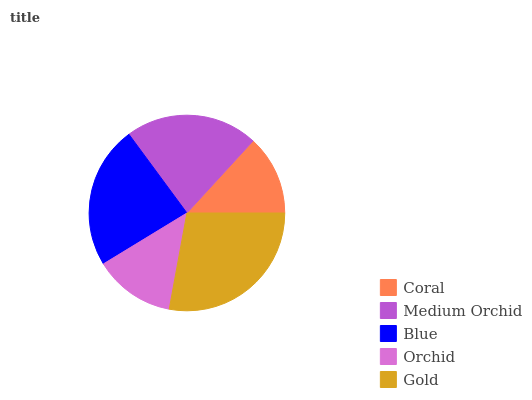Is Coral the minimum?
Answer yes or no. Yes. Is Gold the maximum?
Answer yes or no. Yes. Is Medium Orchid the minimum?
Answer yes or no. No. Is Medium Orchid the maximum?
Answer yes or no. No. Is Medium Orchid greater than Coral?
Answer yes or no. Yes. Is Coral less than Medium Orchid?
Answer yes or no. Yes. Is Coral greater than Medium Orchid?
Answer yes or no. No. Is Medium Orchid less than Coral?
Answer yes or no. No. Is Medium Orchid the high median?
Answer yes or no. Yes. Is Medium Orchid the low median?
Answer yes or no. Yes. Is Blue the high median?
Answer yes or no. No. Is Blue the low median?
Answer yes or no. No. 